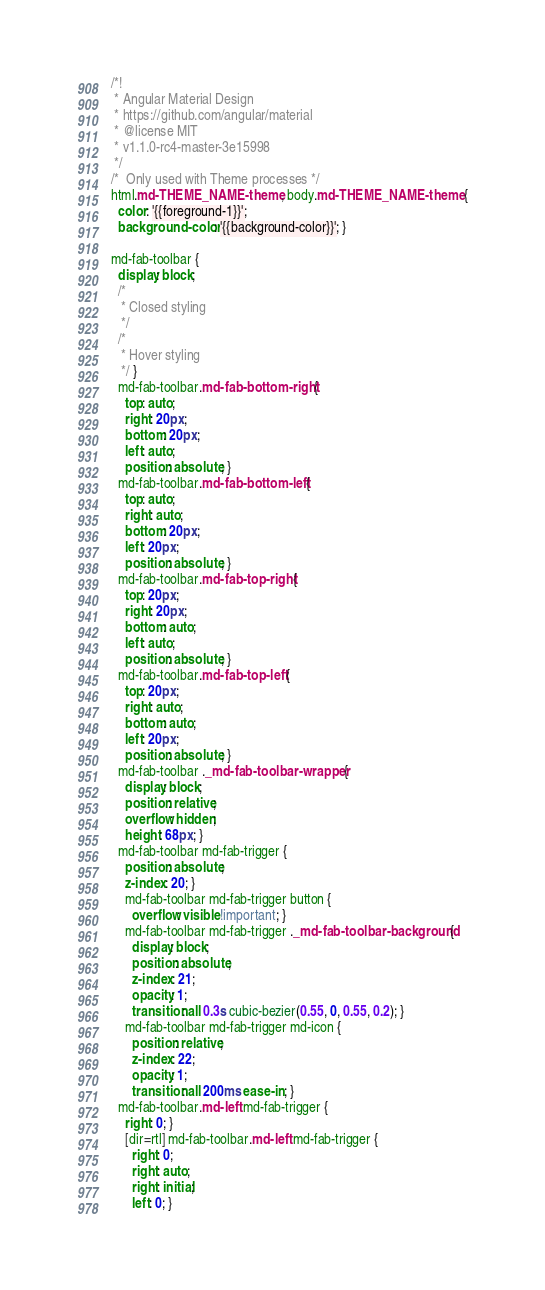Convert code to text. <code><loc_0><loc_0><loc_500><loc_500><_CSS_>/*!
 * Angular Material Design
 * https://github.com/angular/material
 * @license MIT
 * v1.1.0-rc4-master-3e15998
 */
/*  Only used with Theme processes */
html.md-THEME_NAME-theme, body.md-THEME_NAME-theme {
  color: '{{foreground-1}}';
  background-color: '{{background-color}}'; }

md-fab-toolbar {
  display: block;
  /*
   * Closed styling
   */
  /*
   * Hover styling
   */ }
  md-fab-toolbar.md-fab-bottom-right {
    top: auto;
    right: 20px;
    bottom: 20px;
    left: auto;
    position: absolute; }
  md-fab-toolbar.md-fab-bottom-left {
    top: auto;
    right: auto;
    bottom: 20px;
    left: 20px;
    position: absolute; }
  md-fab-toolbar.md-fab-top-right {
    top: 20px;
    right: 20px;
    bottom: auto;
    left: auto;
    position: absolute; }
  md-fab-toolbar.md-fab-top-left {
    top: 20px;
    right: auto;
    bottom: auto;
    left: 20px;
    position: absolute; }
  md-fab-toolbar ._md-fab-toolbar-wrapper {
    display: block;
    position: relative;
    overflow: hidden;
    height: 68px; }
  md-fab-toolbar md-fab-trigger {
    position: absolute;
    z-index: 20; }
    md-fab-toolbar md-fab-trigger button {
      overflow: visible !important; }
    md-fab-toolbar md-fab-trigger ._md-fab-toolbar-background {
      display: block;
      position: absolute;
      z-index: 21;
      opacity: 1;
      transition: all 0.3s cubic-bezier(0.55, 0, 0.55, 0.2); }
    md-fab-toolbar md-fab-trigger md-icon {
      position: relative;
      z-index: 22;
      opacity: 1;
      transition: all 200ms ease-in; }
  md-fab-toolbar.md-left md-fab-trigger {
    right: 0; }
    [dir=rtl] md-fab-toolbar.md-left md-fab-trigger {
      right: 0;
      right: auto;
      right: initial;
      left: 0; }</code> 